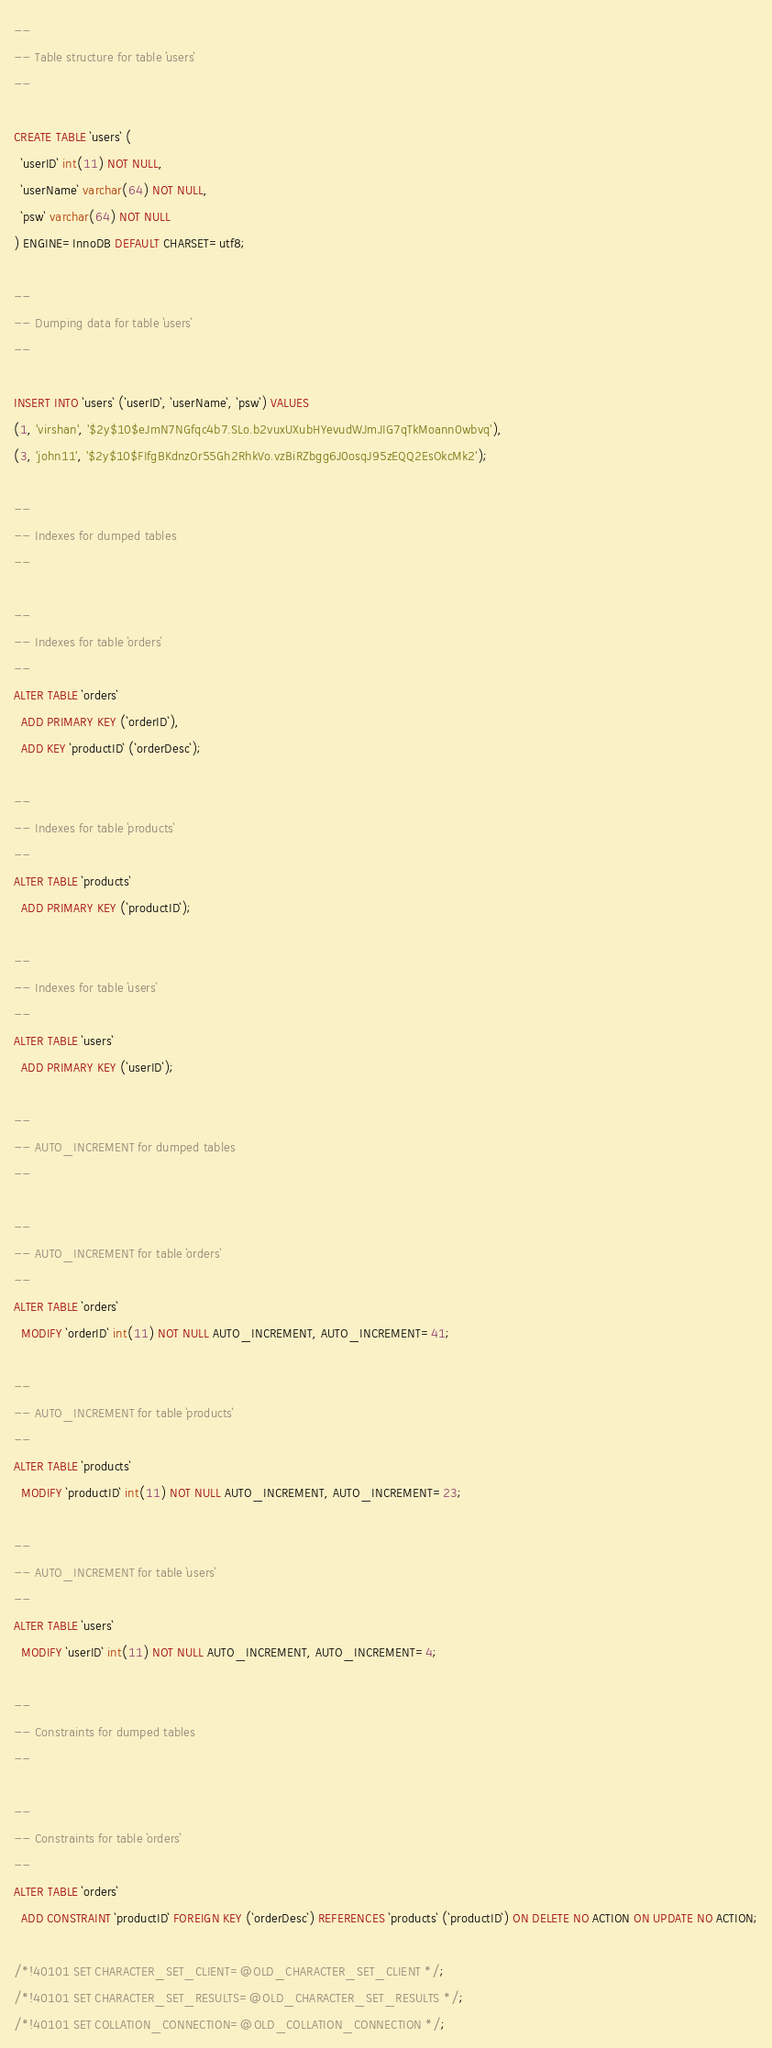<code> <loc_0><loc_0><loc_500><loc_500><_SQL_>
--
-- Table structure for table `users`
--

CREATE TABLE `users` (
  `userID` int(11) NOT NULL,
  `userName` varchar(64) NOT NULL,
  `psw` varchar(64) NOT NULL
) ENGINE=InnoDB DEFAULT CHARSET=utf8;

--
-- Dumping data for table `users`
--

INSERT INTO `users` (`userID`, `userName`, `psw`) VALUES
(1, 'virshan', '$2y$10$eJmN7NGfqc4b7.SLo.b2vuxUXubHYevudWJmJIG7qTkMoann0wbvq'),
(3, 'john11', '$2y$10$FIfgBKdnzOr55Gh2RhkVo.vzBiRZbgg6J0osqJ95zEQQ2EsOkcMk2');

--
-- Indexes for dumped tables
--

--
-- Indexes for table `orders`
--
ALTER TABLE `orders`
  ADD PRIMARY KEY (`orderID`),
  ADD KEY `productID` (`orderDesc`);

--
-- Indexes for table `products`
--
ALTER TABLE `products`
  ADD PRIMARY KEY (`productID`);

--
-- Indexes for table `users`
--
ALTER TABLE `users`
  ADD PRIMARY KEY (`userID`);

--
-- AUTO_INCREMENT for dumped tables
--

--
-- AUTO_INCREMENT for table `orders`
--
ALTER TABLE `orders`
  MODIFY `orderID` int(11) NOT NULL AUTO_INCREMENT, AUTO_INCREMENT=41;

--
-- AUTO_INCREMENT for table `products`
--
ALTER TABLE `products`
  MODIFY `productID` int(11) NOT NULL AUTO_INCREMENT, AUTO_INCREMENT=23;

--
-- AUTO_INCREMENT for table `users`
--
ALTER TABLE `users`
  MODIFY `userID` int(11) NOT NULL AUTO_INCREMENT, AUTO_INCREMENT=4;

--
-- Constraints for dumped tables
--

--
-- Constraints for table `orders`
--
ALTER TABLE `orders`
  ADD CONSTRAINT `productID` FOREIGN KEY (`orderDesc`) REFERENCES `products` (`productID`) ON DELETE NO ACTION ON UPDATE NO ACTION;

/*!40101 SET CHARACTER_SET_CLIENT=@OLD_CHARACTER_SET_CLIENT */;
/*!40101 SET CHARACTER_SET_RESULTS=@OLD_CHARACTER_SET_RESULTS */;
/*!40101 SET COLLATION_CONNECTION=@OLD_COLLATION_CONNECTION */;
</code> 